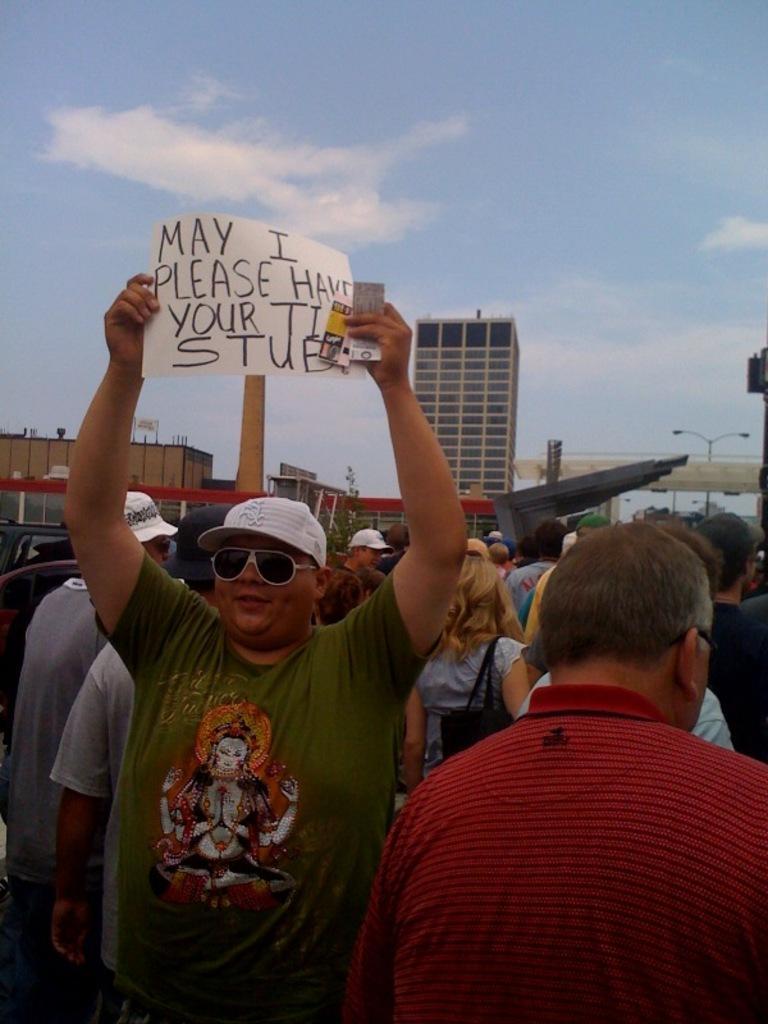Please provide a concise description of this image. At the bottom of the image few people are standing and holding banners. Behind them there are some poles and buildings. At the top of the image there are some clouds and sky. 